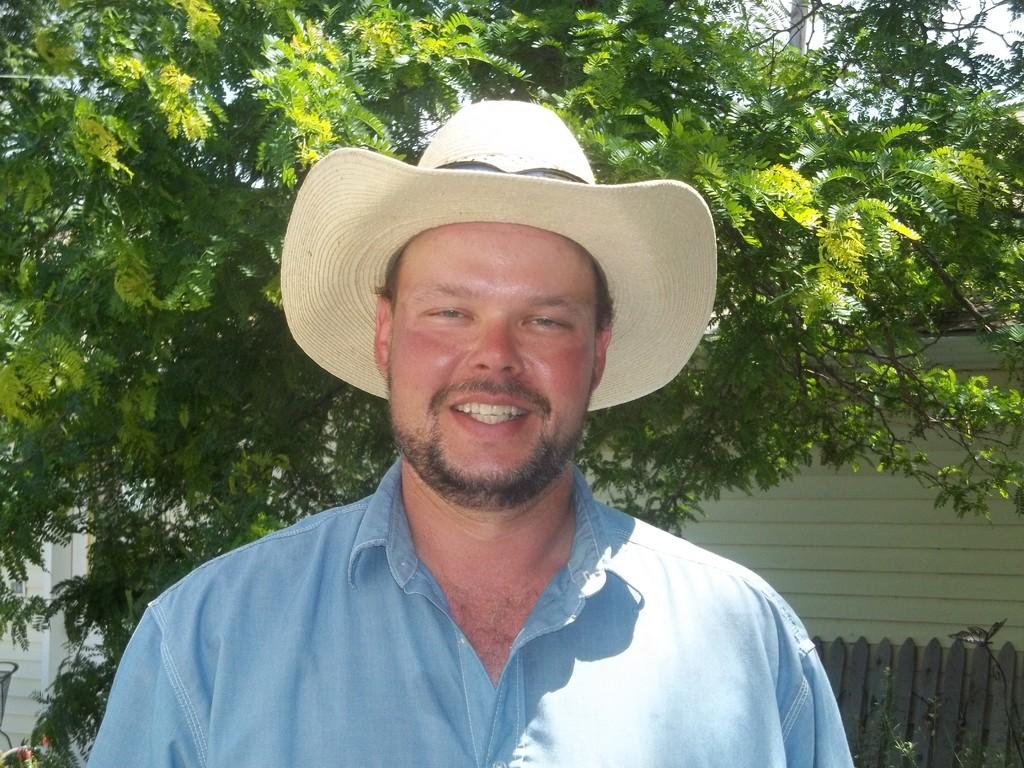Who or what is the main subject in the center of the image? There is a person in the center of the image. What is the person wearing on their head? The person is wearing a hat. What can be seen in the background of the image? There is a wall, fencing, a tree, and the sky visible in the background of the image. What type of stone is the person using as a guide in the image? There is no stone present in the image, and therefore no such activity can be observed. 